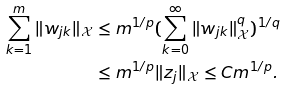<formula> <loc_0><loc_0><loc_500><loc_500>\sum _ { k = 1 } ^ { m } \| w _ { j k } \| _ { \mathcal { X } } & \leq m ^ { 1 / p } ( \sum _ { k = 0 } ^ { \infty } \| w _ { j k } \| _ { \mathcal { X } } ^ { q } ) ^ { 1 / q } \\ & \leq m ^ { 1 / p } \| z _ { j } \| _ { \mathcal { X } } \leq C m ^ { 1 / p } .</formula> 